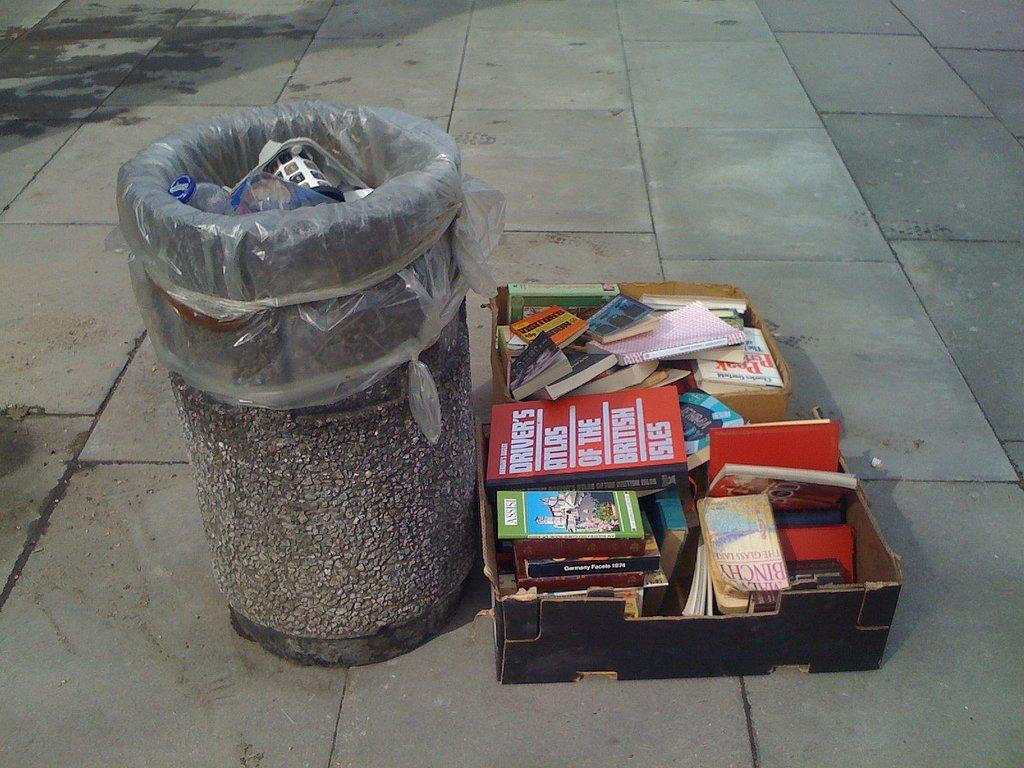<image>
Present a compact description of the photo's key features. A red Drivers Atlas book sits next to a trash can 